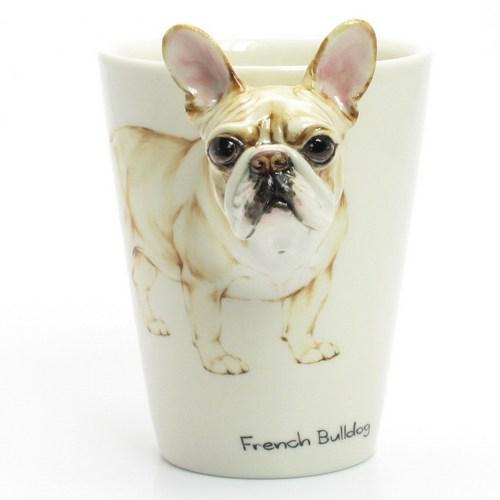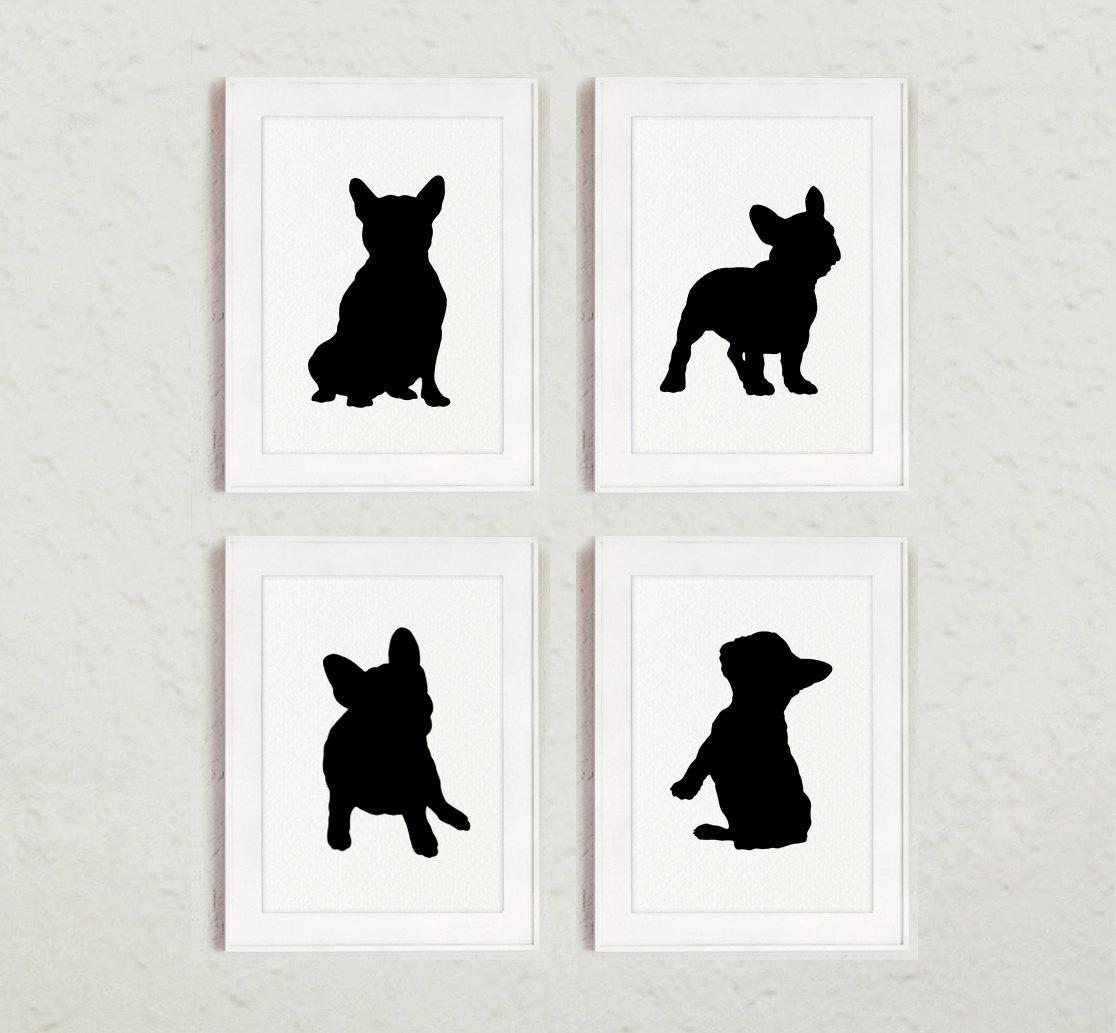The first image is the image on the left, the second image is the image on the right. Given the left and right images, does the statement "There are at least two living breathing Bulldogs looking forward." hold true? Answer yes or no. No. The first image is the image on the left, the second image is the image on the right. For the images displayed, is the sentence "A total of seven dog figures are shown." factually correct? Answer yes or no. No. 